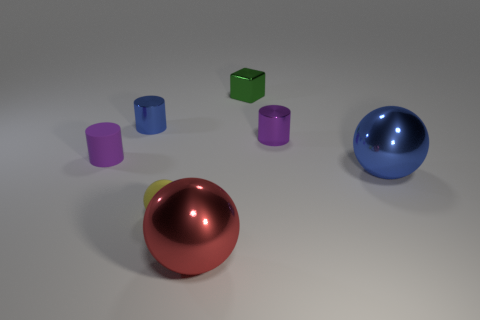Add 3 small blocks. How many objects exist? 10 Subtract all cylinders. How many objects are left? 4 Subtract 0 red cylinders. How many objects are left? 7 Subtract all green rubber balls. Subtract all matte balls. How many objects are left? 6 Add 7 tiny rubber objects. How many tiny rubber objects are left? 9 Add 4 shiny cubes. How many shiny cubes exist? 5 